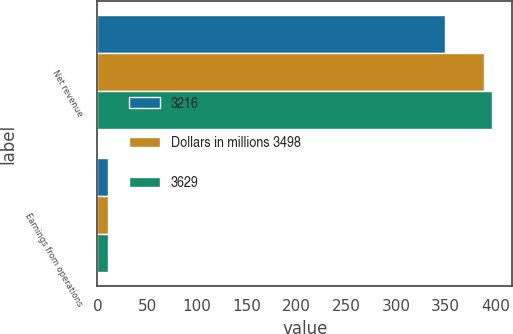<chart> <loc_0><loc_0><loc_500><loc_500><stacked_bar_chart><ecel><fcel>Net revenue<fcel>Earnings from operations<nl><fcel>3216<fcel>349<fcel>10.9<nl><fcel>Dollars in millions 3498<fcel>389<fcel>11.1<nl><fcel>3629<fcel>397<fcel>10.9<nl></chart> 